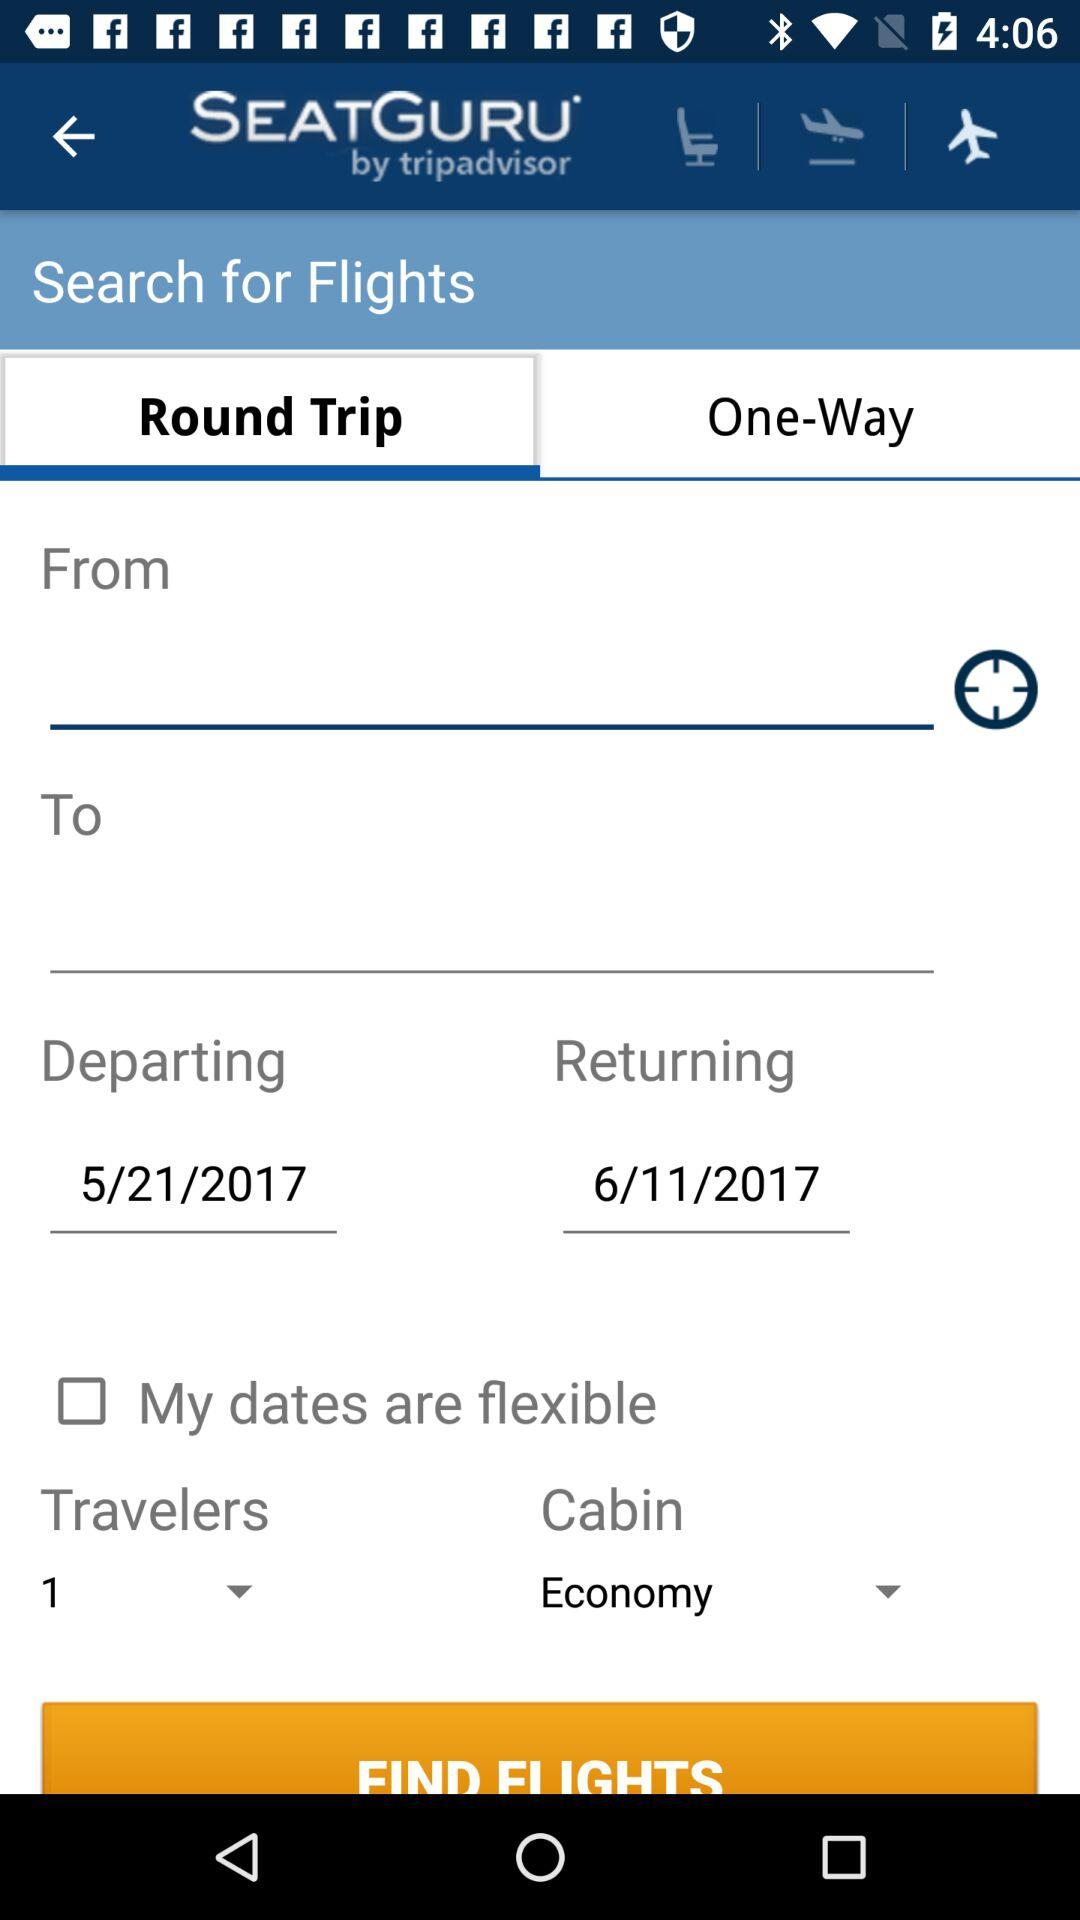Which is the selected tab? The selected tab is "Round Trip". 